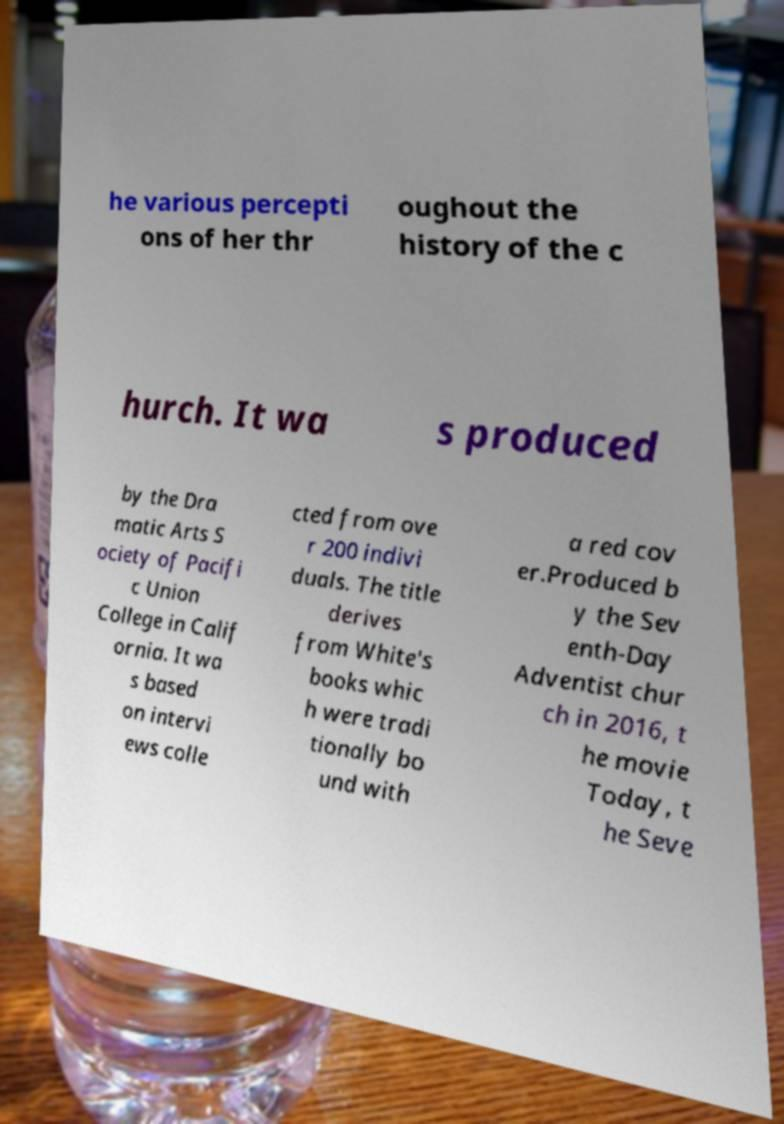What messages or text are displayed in this image? I need them in a readable, typed format. he various percepti ons of her thr oughout the history of the c hurch. It wa s produced by the Dra matic Arts S ociety of Pacifi c Union College in Calif ornia. It wa s based on intervi ews colle cted from ove r 200 indivi duals. The title derives from White's books whic h were tradi tionally bo und with a red cov er.Produced b y the Sev enth-Day Adventist chur ch in 2016, t he movie Today, t he Seve 